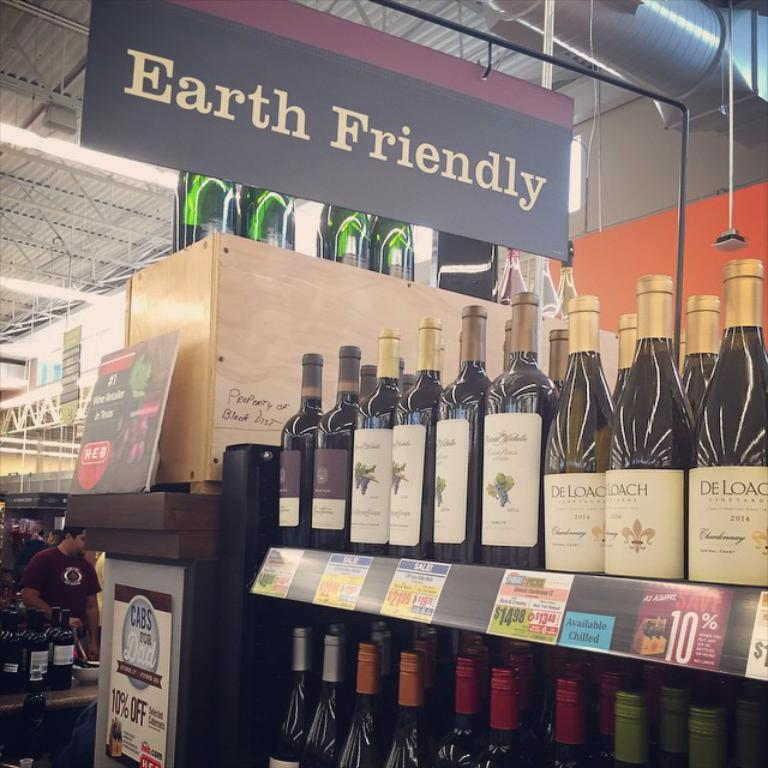<image>
Write a terse but informative summary of the picture. A row of wine bottles in a store say De Loach. 